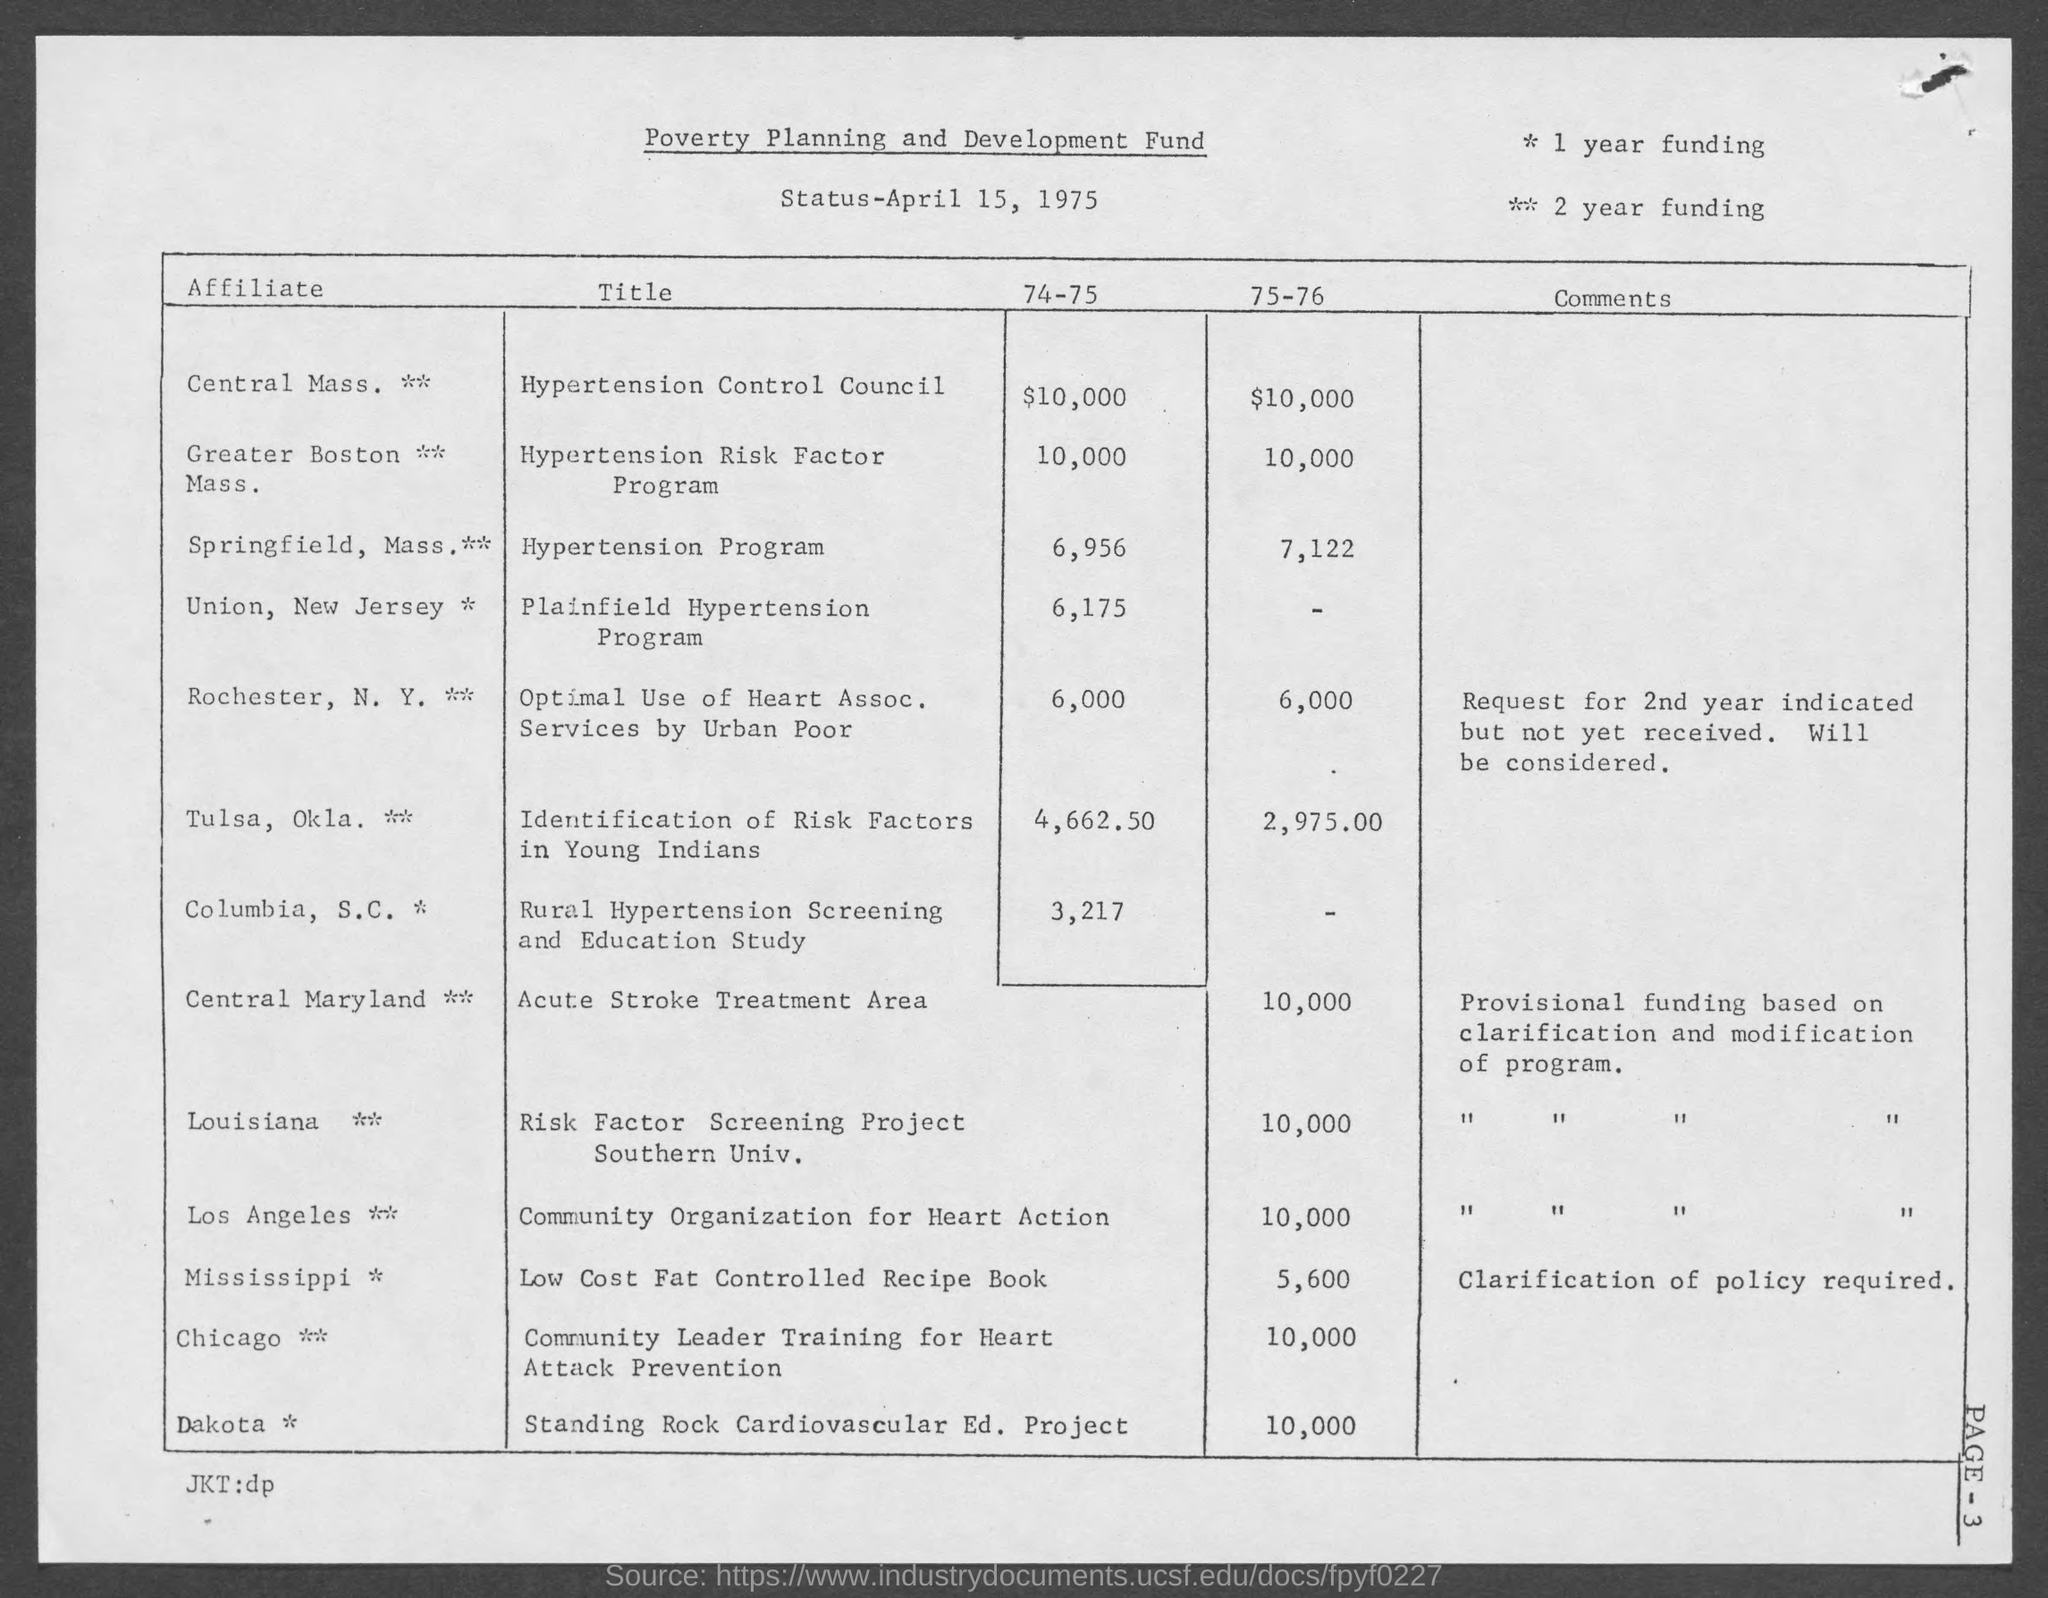What is the date mentioned in this document?
Make the answer very short. April 15, 1975. 